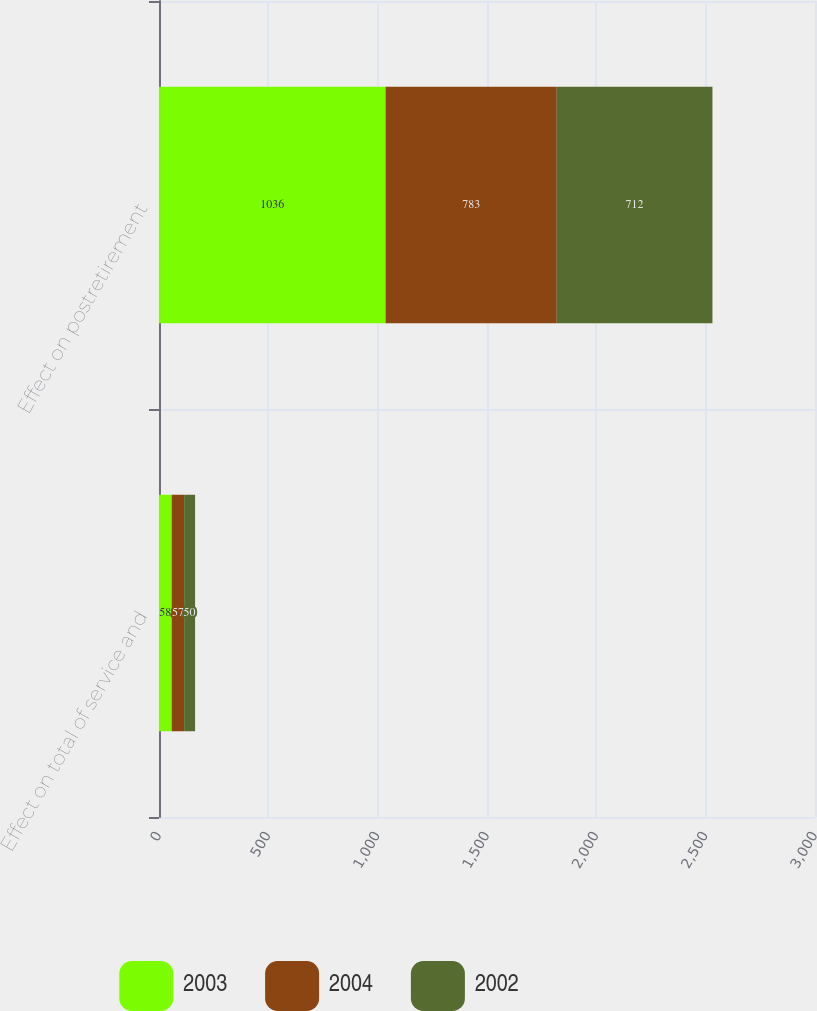Convert chart. <chart><loc_0><loc_0><loc_500><loc_500><stacked_bar_chart><ecel><fcel>Effect on total of service and<fcel>Effect on postretirement<nl><fcel>2003<fcel>58<fcel>1036<nl><fcel>2004<fcel>57<fcel>783<nl><fcel>2002<fcel>50<fcel>712<nl></chart> 